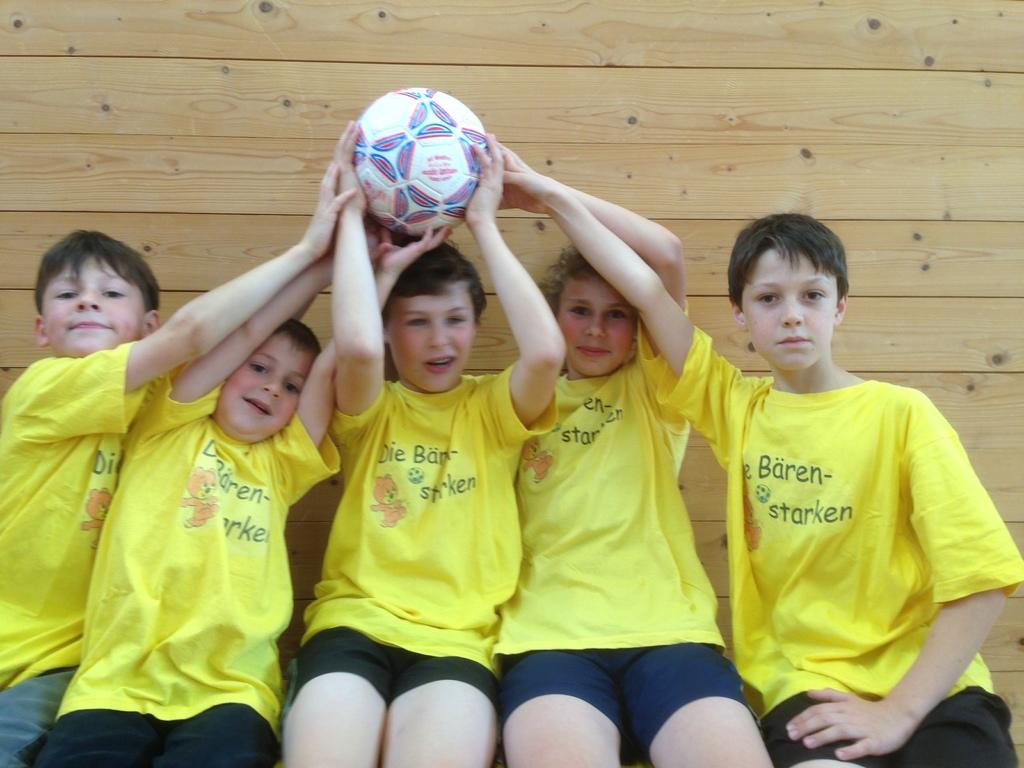What can be seen in the image? There are kids in the image. What are the kids doing? The kids are sitting. What are the kids wearing? The kids are wearing yellow t-shirts. What are the kids holding? The kids are holding a football. What can be seen in the background of the image? There is a brown color wooden wall in the background. What type of street is visible in the image? There is no street visible in the image; it features kids sitting and holding a football, with a brown color wooden wall in the background. How many cubs are present in the image? There are no cubs present in the image; it features kids wearing yellow t-shirts and holding a football. 